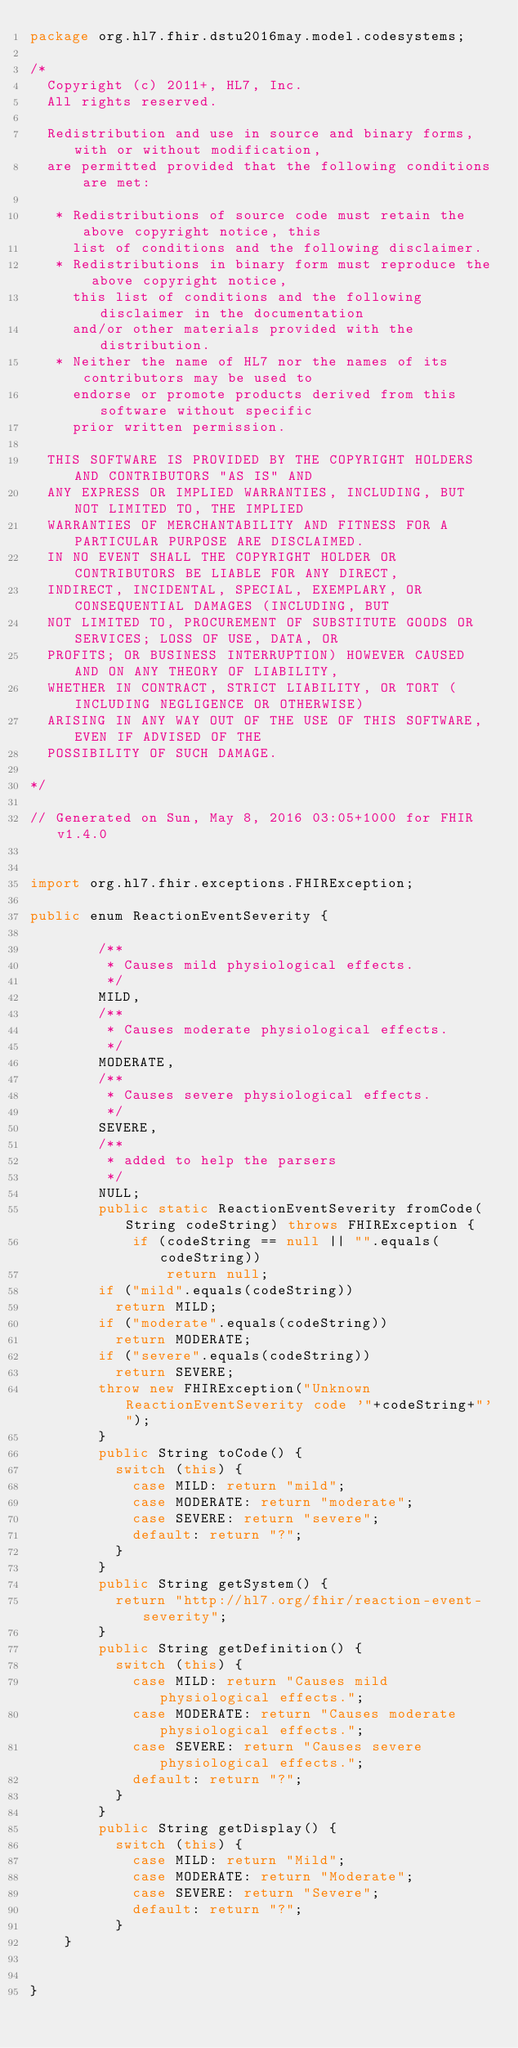Convert code to text. <code><loc_0><loc_0><loc_500><loc_500><_Java_>package org.hl7.fhir.dstu2016may.model.codesystems;

/*
  Copyright (c) 2011+, HL7, Inc.
  All rights reserved.
  
  Redistribution and use in source and binary forms, with or without modification, 
  are permitted provided that the following conditions are met:
  
   * Redistributions of source code must retain the above copyright notice, this 
     list of conditions and the following disclaimer.
   * Redistributions in binary form must reproduce the above copyright notice, 
     this list of conditions and the following disclaimer in the documentation 
     and/or other materials provided with the distribution.
   * Neither the name of HL7 nor the names of its contributors may be used to 
     endorse or promote products derived from this software without specific 
     prior written permission.
  
  THIS SOFTWARE IS PROVIDED BY THE COPYRIGHT HOLDERS AND CONTRIBUTORS "AS IS" AND 
  ANY EXPRESS OR IMPLIED WARRANTIES, INCLUDING, BUT NOT LIMITED TO, THE IMPLIED 
  WARRANTIES OF MERCHANTABILITY AND FITNESS FOR A PARTICULAR PURPOSE ARE DISCLAIMED. 
  IN NO EVENT SHALL THE COPYRIGHT HOLDER OR CONTRIBUTORS BE LIABLE FOR ANY DIRECT, 
  INDIRECT, INCIDENTAL, SPECIAL, EXEMPLARY, OR CONSEQUENTIAL DAMAGES (INCLUDING, BUT 
  NOT LIMITED TO, PROCUREMENT OF SUBSTITUTE GOODS OR SERVICES; LOSS OF USE, DATA, OR 
  PROFITS; OR BUSINESS INTERRUPTION) HOWEVER CAUSED AND ON ANY THEORY OF LIABILITY, 
  WHETHER IN CONTRACT, STRICT LIABILITY, OR TORT (INCLUDING NEGLIGENCE OR OTHERWISE) 
  ARISING IN ANY WAY OUT OF THE USE OF THIS SOFTWARE, EVEN IF ADVISED OF THE 
  POSSIBILITY OF SUCH DAMAGE.
  
*/

// Generated on Sun, May 8, 2016 03:05+1000 for FHIR v1.4.0


import org.hl7.fhir.exceptions.FHIRException;

public enum ReactionEventSeverity {

        /**
         * Causes mild physiological effects.
         */
        MILD, 
        /**
         * Causes moderate physiological effects.
         */
        MODERATE, 
        /**
         * Causes severe physiological effects.
         */
        SEVERE, 
        /**
         * added to help the parsers
         */
        NULL;
        public static ReactionEventSeverity fromCode(String codeString) throws FHIRException {
            if (codeString == null || "".equals(codeString))
                return null;
        if ("mild".equals(codeString))
          return MILD;
        if ("moderate".equals(codeString))
          return MODERATE;
        if ("severe".equals(codeString))
          return SEVERE;
        throw new FHIRException("Unknown ReactionEventSeverity code '"+codeString+"'");
        }
        public String toCode() {
          switch (this) {
            case MILD: return "mild";
            case MODERATE: return "moderate";
            case SEVERE: return "severe";
            default: return "?";
          }
        }
        public String getSystem() {
          return "http://hl7.org/fhir/reaction-event-severity";
        }
        public String getDefinition() {
          switch (this) {
            case MILD: return "Causes mild physiological effects.";
            case MODERATE: return "Causes moderate physiological effects.";
            case SEVERE: return "Causes severe physiological effects.";
            default: return "?";
          }
        }
        public String getDisplay() {
          switch (this) {
            case MILD: return "Mild";
            case MODERATE: return "Moderate";
            case SEVERE: return "Severe";
            default: return "?";
          }
    }


}

</code> 